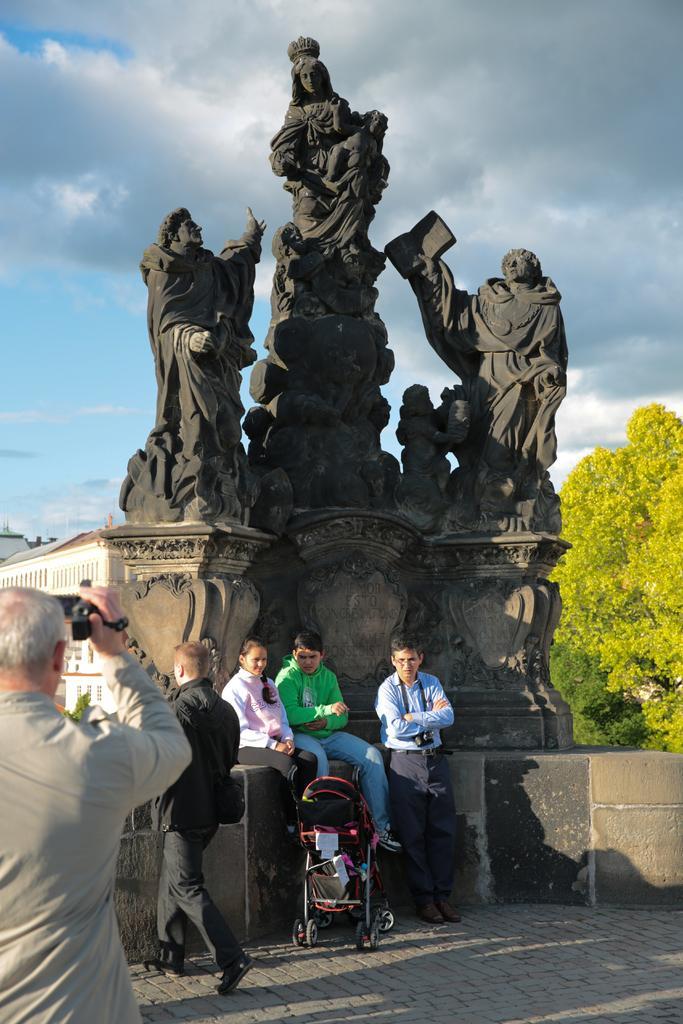Please provide a concise description of this image. On the left side a man is standing and holding a camera in his hand and there are two persons sitting on a platform and a man is walking on the road and there is a stroller and a person is standing at the platform. In the background there are statutes on a platform,trees,buildings and clouds in the sky. 